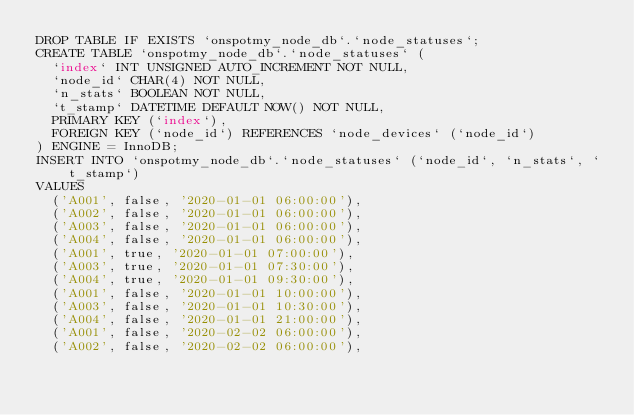<code> <loc_0><loc_0><loc_500><loc_500><_SQL_>DROP TABLE IF EXISTS `onspotmy_node_db`.`node_statuses`;
CREATE TABLE `onspotmy_node_db`.`node_statuses` (
  `index` INT UNSIGNED AUTO_INCREMENT NOT NULL,
  `node_id` CHAR(4) NOT NULL,
  `n_stats` BOOLEAN NOT NULL,
  `t_stamp` DATETIME DEFAULT NOW() NOT NULL,
  PRIMARY KEY (`index`),
  FOREIGN KEY (`node_id`) REFERENCES `node_devices` (`node_id`)
) ENGINE = InnoDB;
INSERT INTO `onspotmy_node_db`.`node_statuses` (`node_id`, `n_stats`, `t_stamp`)
VALUES
  ('A001', false, '2020-01-01 06:00:00'),
  ('A002', false, '2020-01-01 06:00:00'),
  ('A003', false, '2020-01-01 06:00:00'),
  ('A004', false, '2020-01-01 06:00:00'),
  ('A001', true, '2020-01-01 07:00:00'),
  ('A003', true, '2020-01-01 07:30:00'),
  ('A004', true, '2020-01-01 09:30:00'),
  ('A001', false, '2020-01-01 10:00:00'),
  ('A003', false, '2020-01-01 10:30:00'),
  ('A004', false, '2020-01-01 21:00:00'),
  ('A001', false, '2020-02-02 06:00:00'),
  ('A002', false, '2020-02-02 06:00:00'),</code> 